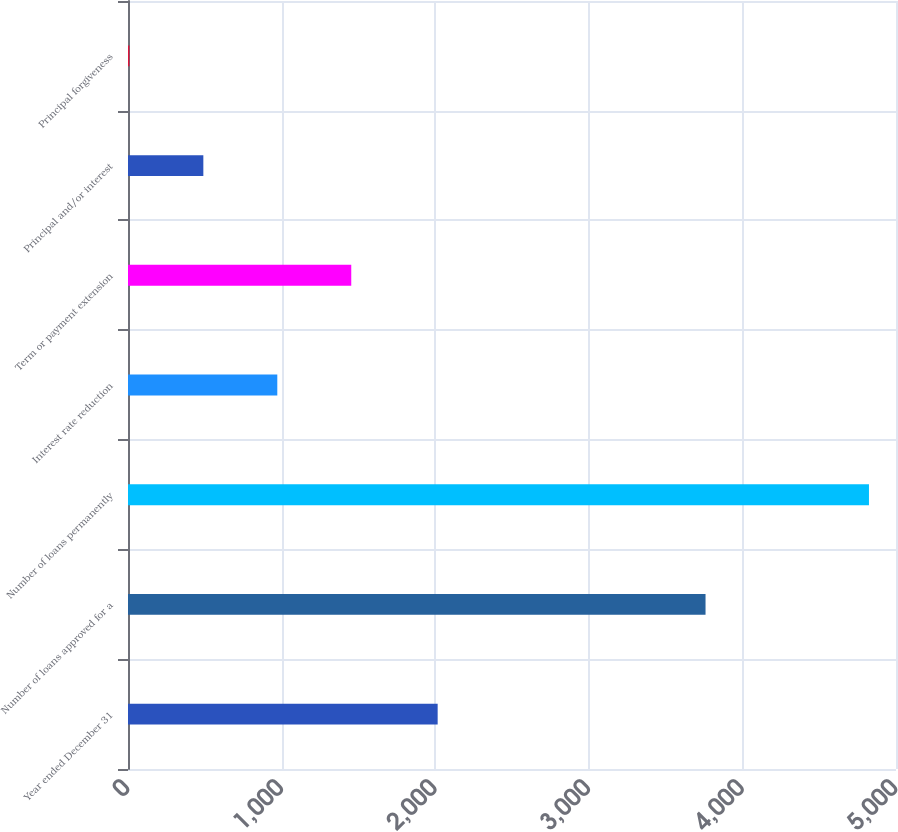Convert chart. <chart><loc_0><loc_0><loc_500><loc_500><bar_chart><fcel>Year ended December 31<fcel>Number of loans approved for a<fcel>Number of loans permanently<fcel>Interest rate reduction<fcel>Term or payment extension<fcel>Principal and/or interest<fcel>Principal forgiveness<nl><fcel>2016<fcel>3760<fcel>4824<fcel>972<fcel>1453.5<fcel>490.5<fcel>9<nl></chart> 